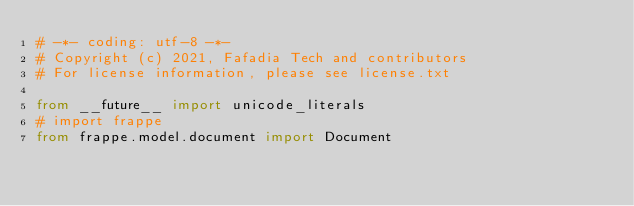Convert code to text. <code><loc_0><loc_0><loc_500><loc_500><_Python_># -*- coding: utf-8 -*-
# Copyright (c) 2021, Fafadia Tech and contributors
# For license information, please see license.txt

from __future__ import unicode_literals
# import frappe
from frappe.model.document import Document
</code> 